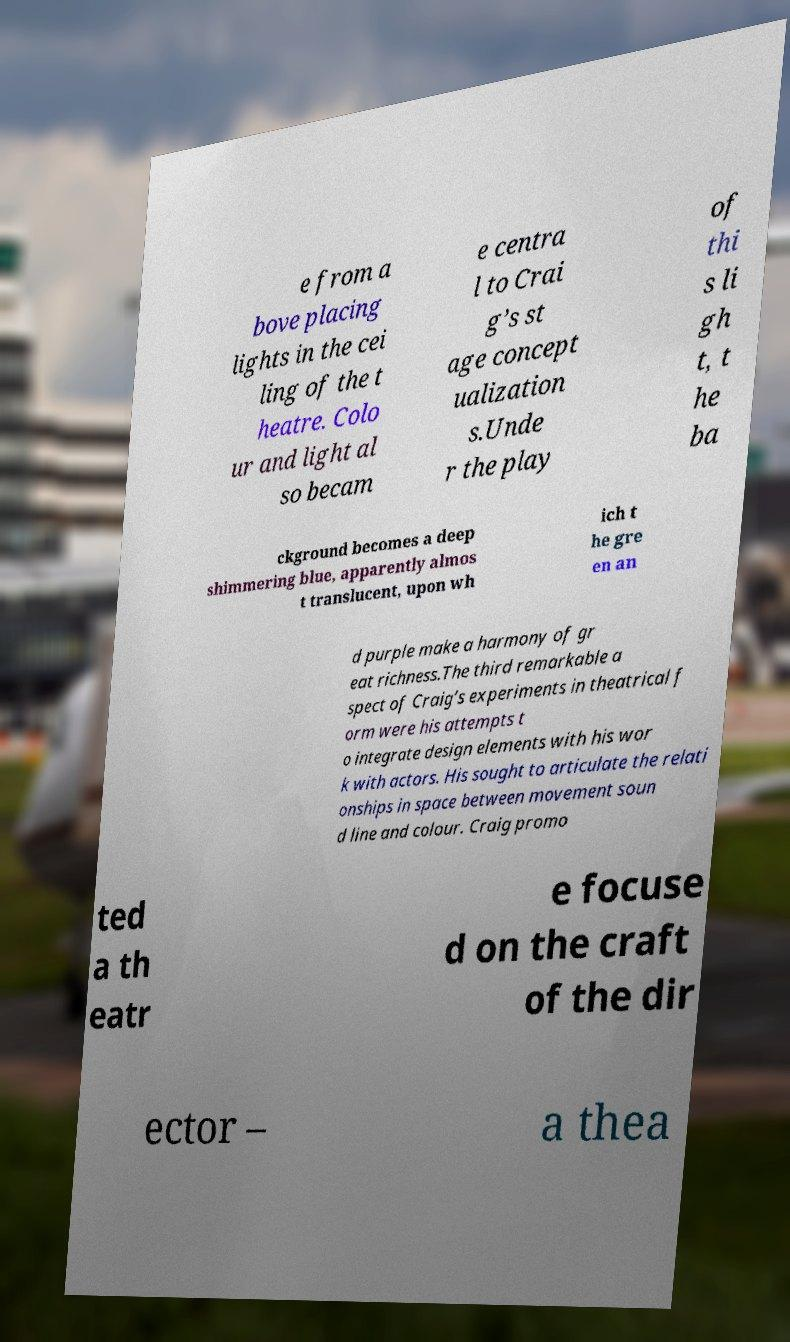Can you read and provide the text displayed in the image?This photo seems to have some interesting text. Can you extract and type it out for me? e from a bove placing lights in the cei ling of the t heatre. Colo ur and light al so becam e centra l to Crai g’s st age concept ualization s.Unde r the play of thi s li gh t, t he ba ckground becomes a deep shimmering blue, apparently almos t translucent, upon wh ich t he gre en an d purple make a harmony of gr eat richness.The third remarkable a spect of Craig’s experiments in theatrical f orm were his attempts t o integrate design elements with his wor k with actors. His sought to articulate the relati onships in space between movement soun d line and colour. Craig promo ted a th eatr e focuse d on the craft of the dir ector – a thea 